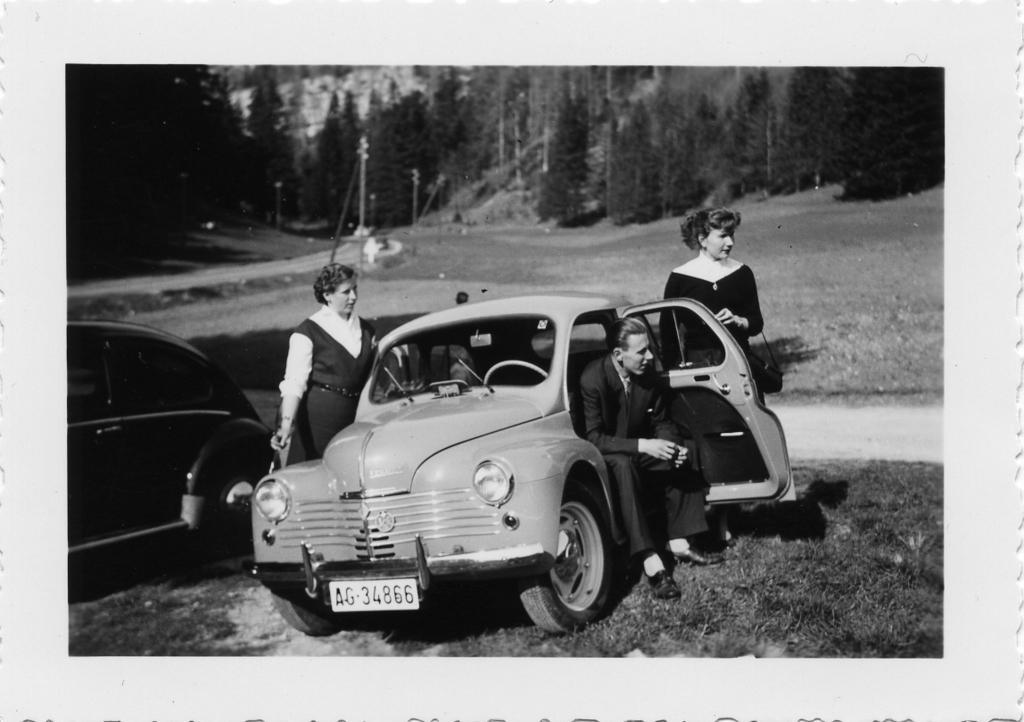How would you summarize this image in a sentence or two? In this picture there is a guy sitting inside a car and two people standing outside the car. There is a car to the left of the image. In the background there are many trees. 